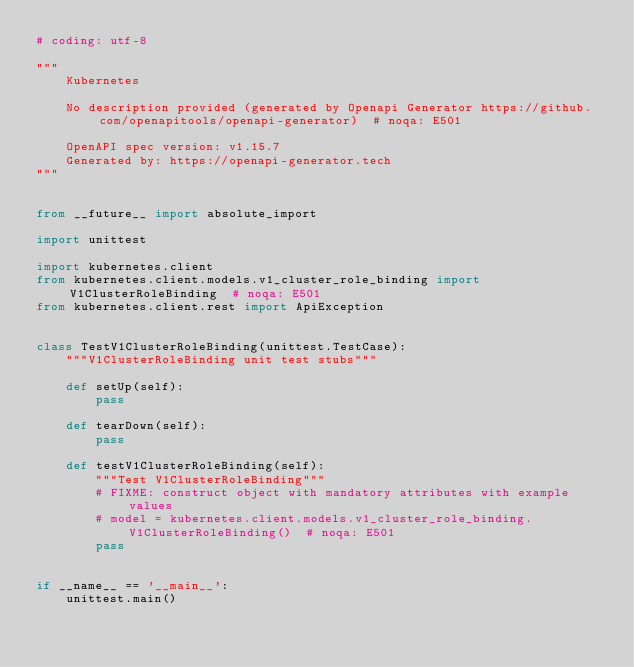<code> <loc_0><loc_0><loc_500><loc_500><_Python_># coding: utf-8

"""
    Kubernetes

    No description provided (generated by Openapi Generator https://github.com/openapitools/openapi-generator)  # noqa: E501

    OpenAPI spec version: v1.15.7
    Generated by: https://openapi-generator.tech
"""


from __future__ import absolute_import

import unittest

import kubernetes.client
from kubernetes.client.models.v1_cluster_role_binding import V1ClusterRoleBinding  # noqa: E501
from kubernetes.client.rest import ApiException


class TestV1ClusterRoleBinding(unittest.TestCase):
    """V1ClusterRoleBinding unit test stubs"""

    def setUp(self):
        pass

    def tearDown(self):
        pass

    def testV1ClusterRoleBinding(self):
        """Test V1ClusterRoleBinding"""
        # FIXME: construct object with mandatory attributes with example values
        # model = kubernetes.client.models.v1_cluster_role_binding.V1ClusterRoleBinding()  # noqa: E501
        pass


if __name__ == '__main__':
    unittest.main()
</code> 